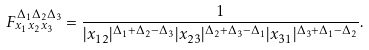Convert formula to latex. <formula><loc_0><loc_0><loc_500><loc_500>F _ { x _ { 1 } x _ { 2 } x _ { 3 } } ^ { \Delta _ { 1 } \Delta _ { 2 } \Delta _ { 3 } } = \frac { 1 } { | x _ { 1 2 } | ^ { \Delta _ { 1 } + \Delta _ { 2 } - \Delta _ { 3 } } | x _ { 2 3 } | ^ { \Delta _ { 2 } + \Delta _ { 3 } - \Delta _ { 1 } } | x _ { 3 1 } | ^ { \Delta _ { 3 } + \Delta _ { 1 } - \Delta _ { 2 } } } .</formula> 